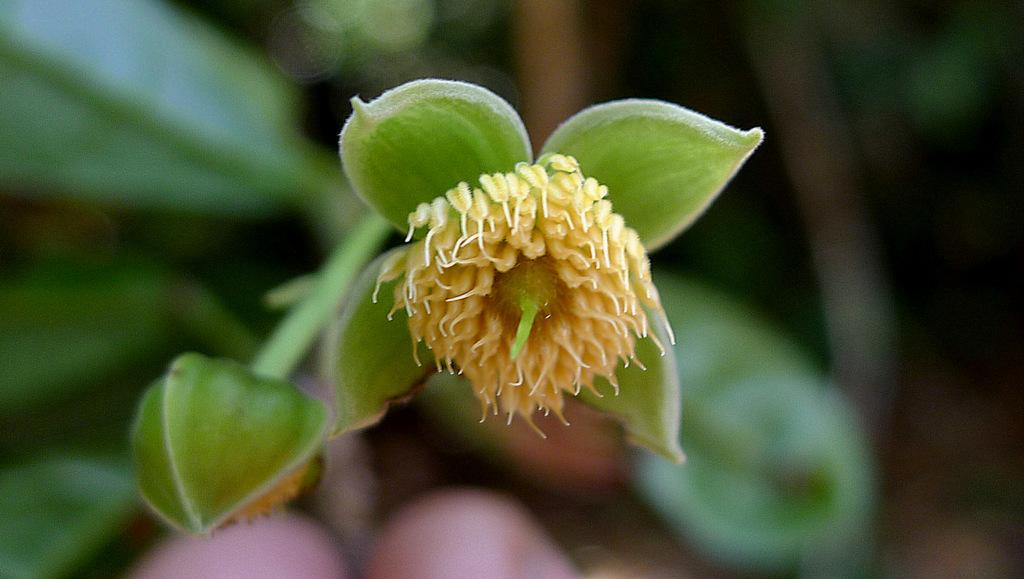What is present in the image? There is a flower in the image. What can be observed on the flower? The flower has pollen grains. Can you describe the growth stage of another flower in the image? There is a bud on the left side of the image. What type of lunch is the flower eating in the image? There is no indication in the image that the flower is eating lunch, as flowers do not consume food like humans do. 